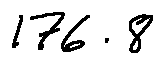Convert formula to latex. <formula><loc_0><loc_0><loc_500><loc_500>1 7 6 . 8</formula> 